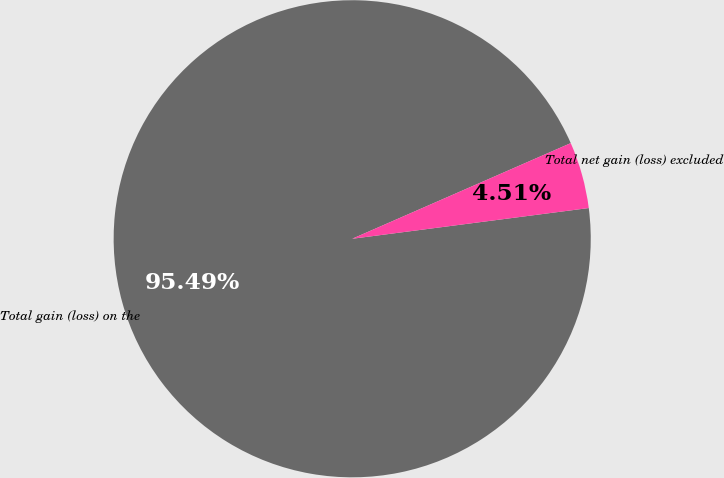<chart> <loc_0><loc_0><loc_500><loc_500><pie_chart><fcel>Total gain (loss) on the<fcel>Total net gain (loss) excluded<nl><fcel>95.49%<fcel>4.51%<nl></chart> 